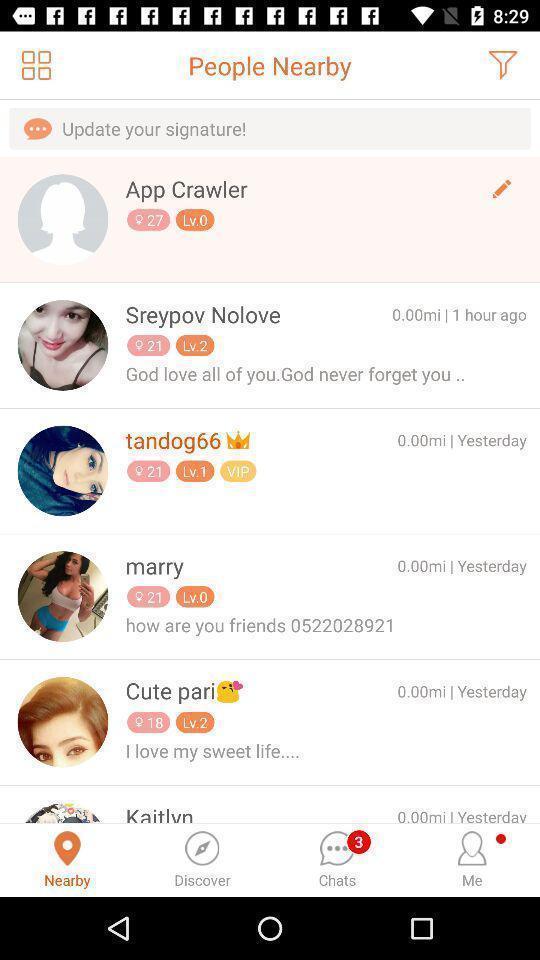Describe the visual elements of this screenshot. Screen shows list of profiles in a communication app. 